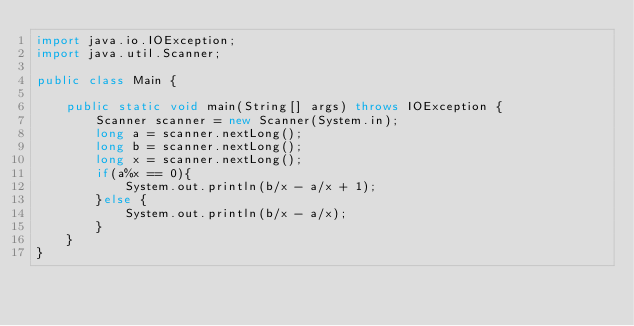Convert code to text. <code><loc_0><loc_0><loc_500><loc_500><_Java_>import java.io.IOException;
import java.util.Scanner;

public class Main {

	public static void main(String[] args) throws IOException {
		Scanner scanner = new Scanner(System.in);
		long a = scanner.nextLong();
		long b = scanner.nextLong();
		long x = scanner.nextLong();
		if(a%x == 0){
			System.out.println(b/x - a/x + 1);
		}else {
			System.out.println(b/x - a/x);
		}
	}
}</code> 